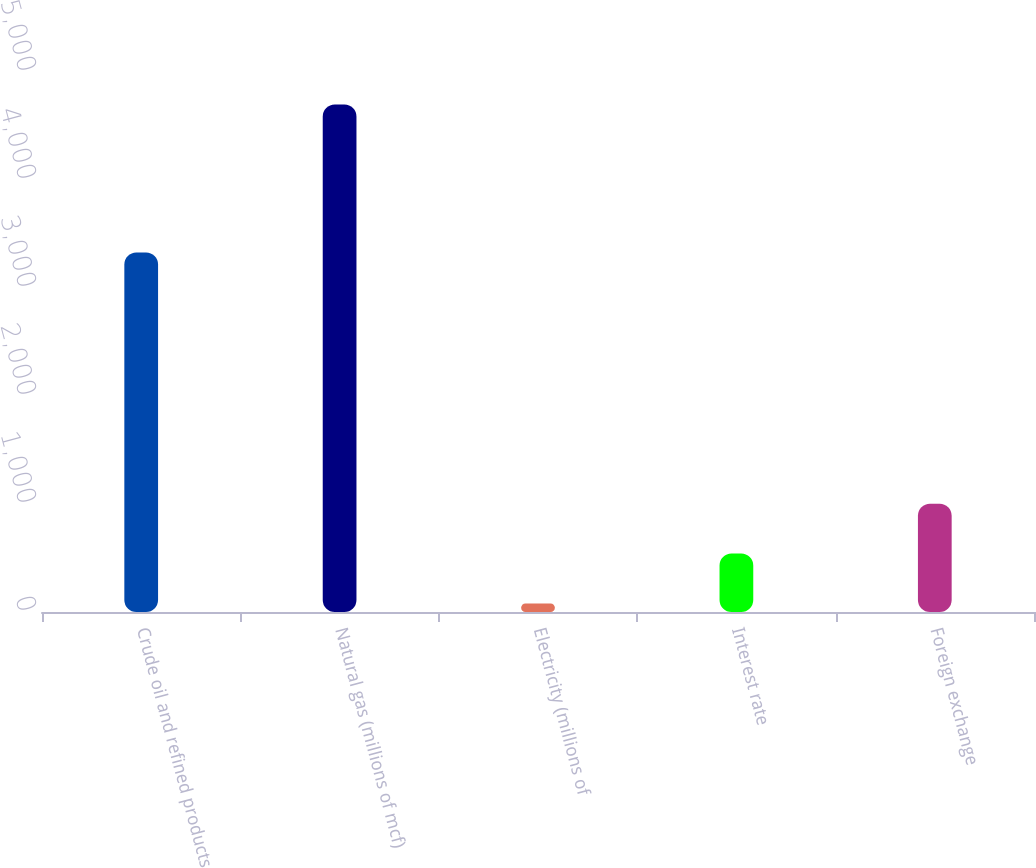<chart> <loc_0><loc_0><loc_500><loc_500><bar_chart><fcel>Crude oil and refined products<fcel>Natural gas (millions of mcf)<fcel>Electricity (millions of<fcel>Interest rate<fcel>Foreign exchange<nl><fcel>3328<fcel>4699<fcel>79<fcel>541<fcel>1003<nl></chart> 